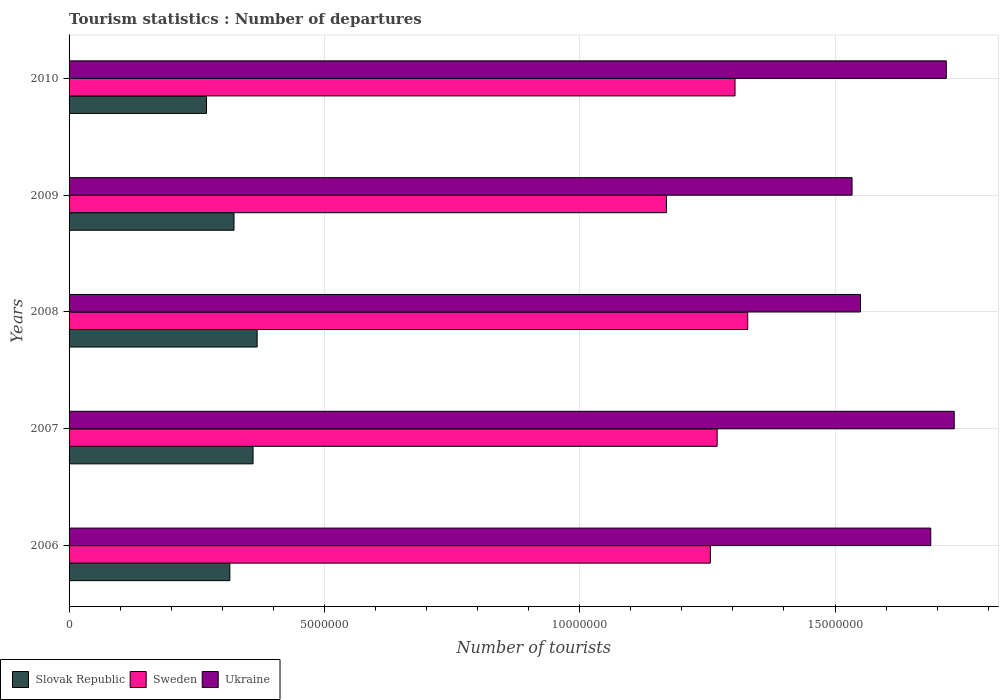How many groups of bars are there?
Keep it short and to the point. 5. Are the number of bars per tick equal to the number of legend labels?
Give a very brief answer. Yes. In how many cases, is the number of bars for a given year not equal to the number of legend labels?
Keep it short and to the point. 0. What is the number of tourist departures in Ukraine in 2007?
Make the answer very short. 1.73e+07. Across all years, what is the maximum number of tourist departures in Slovak Republic?
Ensure brevity in your answer.  3.68e+06. Across all years, what is the minimum number of tourist departures in Slovak Republic?
Ensure brevity in your answer.  2.69e+06. What is the total number of tourist departures in Ukraine in the graph?
Keep it short and to the point. 8.22e+07. What is the difference between the number of tourist departures in Ukraine in 2006 and that in 2007?
Offer a terse response. -4.60e+05. What is the difference between the number of tourist departures in Slovak Republic in 2006 and the number of tourist departures in Ukraine in 2010?
Offer a terse response. -1.40e+07. What is the average number of tourist departures in Slovak Republic per year?
Keep it short and to the point. 3.27e+06. In the year 2006, what is the difference between the number of tourist departures in Sweden and number of tourist departures in Slovak Republic?
Ensure brevity in your answer.  9.41e+06. What is the ratio of the number of tourist departures in Ukraine in 2006 to that in 2008?
Provide a short and direct response. 1.09. Is the number of tourist departures in Slovak Republic in 2008 less than that in 2010?
Your answer should be very brief. No. Is the difference between the number of tourist departures in Sweden in 2006 and 2010 greater than the difference between the number of tourist departures in Slovak Republic in 2006 and 2010?
Offer a terse response. No. What is the difference between the highest and the second highest number of tourist departures in Sweden?
Provide a succinct answer. 2.49e+05. What is the difference between the highest and the lowest number of tourist departures in Sweden?
Provide a short and direct response. 1.59e+06. What does the 1st bar from the top in 2009 represents?
Ensure brevity in your answer.  Ukraine. What does the 3rd bar from the bottom in 2008 represents?
Provide a short and direct response. Ukraine. Is it the case that in every year, the sum of the number of tourist departures in Sweden and number of tourist departures in Ukraine is greater than the number of tourist departures in Slovak Republic?
Your answer should be compact. Yes. How many bars are there?
Give a very brief answer. 15. Are all the bars in the graph horizontal?
Keep it short and to the point. Yes. How many years are there in the graph?
Offer a terse response. 5. Does the graph contain any zero values?
Provide a short and direct response. No. What is the title of the graph?
Offer a very short reply. Tourism statistics : Number of departures. What is the label or title of the X-axis?
Offer a very short reply. Number of tourists. What is the Number of tourists in Slovak Republic in 2006?
Provide a short and direct response. 3.15e+06. What is the Number of tourists of Sweden in 2006?
Offer a terse response. 1.26e+07. What is the Number of tourists of Ukraine in 2006?
Make the answer very short. 1.69e+07. What is the Number of tourists in Slovak Republic in 2007?
Give a very brief answer. 3.60e+06. What is the Number of tourists of Sweden in 2007?
Ensure brevity in your answer.  1.27e+07. What is the Number of tourists of Ukraine in 2007?
Offer a terse response. 1.73e+07. What is the Number of tourists of Slovak Republic in 2008?
Provide a succinct answer. 3.68e+06. What is the Number of tourists of Sweden in 2008?
Offer a very short reply. 1.33e+07. What is the Number of tourists of Ukraine in 2008?
Keep it short and to the point. 1.55e+07. What is the Number of tourists of Slovak Republic in 2009?
Your response must be concise. 3.23e+06. What is the Number of tourists of Sweden in 2009?
Your response must be concise. 1.17e+07. What is the Number of tourists in Ukraine in 2009?
Offer a terse response. 1.53e+07. What is the Number of tourists of Slovak Republic in 2010?
Your answer should be very brief. 2.69e+06. What is the Number of tourists of Sweden in 2010?
Make the answer very short. 1.30e+07. What is the Number of tourists of Ukraine in 2010?
Make the answer very short. 1.72e+07. Across all years, what is the maximum Number of tourists of Slovak Republic?
Offer a very short reply. 3.68e+06. Across all years, what is the maximum Number of tourists of Sweden?
Give a very brief answer. 1.33e+07. Across all years, what is the maximum Number of tourists of Ukraine?
Your answer should be very brief. 1.73e+07. Across all years, what is the minimum Number of tourists in Slovak Republic?
Ensure brevity in your answer.  2.69e+06. Across all years, what is the minimum Number of tourists of Sweden?
Your answer should be very brief. 1.17e+07. Across all years, what is the minimum Number of tourists in Ukraine?
Make the answer very short. 1.53e+07. What is the total Number of tourists of Slovak Republic in the graph?
Give a very brief answer. 1.64e+07. What is the total Number of tourists in Sweden in the graph?
Keep it short and to the point. 6.33e+07. What is the total Number of tourists of Ukraine in the graph?
Ensure brevity in your answer.  8.22e+07. What is the difference between the Number of tourists in Slovak Republic in 2006 and that in 2007?
Your response must be concise. -4.54e+05. What is the difference between the Number of tourists in Sweden in 2006 and that in 2007?
Offer a very short reply. -1.33e+05. What is the difference between the Number of tourists in Ukraine in 2006 and that in 2007?
Provide a short and direct response. -4.60e+05. What is the difference between the Number of tourists in Slovak Republic in 2006 and that in 2008?
Your answer should be compact. -5.34e+05. What is the difference between the Number of tourists in Sweden in 2006 and that in 2008?
Give a very brief answer. -7.32e+05. What is the difference between the Number of tourists of Ukraine in 2006 and that in 2008?
Make the answer very short. 1.38e+06. What is the difference between the Number of tourists in Slovak Republic in 2006 and that in 2009?
Offer a terse response. -8.10e+04. What is the difference between the Number of tourists in Sweden in 2006 and that in 2009?
Make the answer very short. 8.60e+05. What is the difference between the Number of tourists in Ukraine in 2006 and that in 2009?
Ensure brevity in your answer.  1.54e+06. What is the difference between the Number of tourists in Slovak Republic in 2006 and that in 2010?
Offer a terse response. 4.57e+05. What is the difference between the Number of tourists in Sweden in 2006 and that in 2010?
Make the answer very short. -4.83e+05. What is the difference between the Number of tourists of Ukraine in 2006 and that in 2010?
Your answer should be compact. -3.05e+05. What is the difference between the Number of tourists of Slovak Republic in 2007 and that in 2008?
Offer a very short reply. -8.00e+04. What is the difference between the Number of tourists of Sweden in 2007 and that in 2008?
Offer a terse response. -5.99e+05. What is the difference between the Number of tourists in Ukraine in 2007 and that in 2008?
Keep it short and to the point. 1.84e+06. What is the difference between the Number of tourists in Slovak Republic in 2007 and that in 2009?
Your response must be concise. 3.73e+05. What is the difference between the Number of tourists in Sweden in 2007 and that in 2009?
Keep it short and to the point. 9.93e+05. What is the difference between the Number of tourists of Ukraine in 2007 and that in 2009?
Offer a terse response. 2.00e+06. What is the difference between the Number of tourists of Slovak Republic in 2007 and that in 2010?
Offer a very short reply. 9.11e+05. What is the difference between the Number of tourists in Sweden in 2007 and that in 2010?
Offer a very short reply. -3.50e+05. What is the difference between the Number of tourists of Ukraine in 2007 and that in 2010?
Offer a terse response. 1.55e+05. What is the difference between the Number of tourists in Slovak Republic in 2008 and that in 2009?
Make the answer very short. 4.53e+05. What is the difference between the Number of tourists of Sweden in 2008 and that in 2009?
Your response must be concise. 1.59e+06. What is the difference between the Number of tourists of Ukraine in 2008 and that in 2009?
Your answer should be compact. 1.65e+05. What is the difference between the Number of tourists of Slovak Republic in 2008 and that in 2010?
Make the answer very short. 9.91e+05. What is the difference between the Number of tourists in Sweden in 2008 and that in 2010?
Keep it short and to the point. 2.49e+05. What is the difference between the Number of tourists of Ukraine in 2008 and that in 2010?
Make the answer very short. -1.68e+06. What is the difference between the Number of tourists in Slovak Republic in 2009 and that in 2010?
Provide a succinct answer. 5.38e+05. What is the difference between the Number of tourists of Sweden in 2009 and that in 2010?
Make the answer very short. -1.34e+06. What is the difference between the Number of tourists of Ukraine in 2009 and that in 2010?
Provide a succinct answer. -1.85e+06. What is the difference between the Number of tourists in Slovak Republic in 2006 and the Number of tourists in Sweden in 2007?
Offer a very short reply. -9.54e+06. What is the difference between the Number of tourists in Slovak Republic in 2006 and the Number of tourists in Ukraine in 2007?
Keep it short and to the point. -1.42e+07. What is the difference between the Number of tourists of Sweden in 2006 and the Number of tourists of Ukraine in 2007?
Your answer should be compact. -4.78e+06. What is the difference between the Number of tourists in Slovak Republic in 2006 and the Number of tourists in Sweden in 2008?
Offer a terse response. -1.01e+07. What is the difference between the Number of tourists in Slovak Republic in 2006 and the Number of tourists in Ukraine in 2008?
Keep it short and to the point. -1.24e+07. What is the difference between the Number of tourists in Sweden in 2006 and the Number of tourists in Ukraine in 2008?
Make the answer very short. -2.94e+06. What is the difference between the Number of tourists in Slovak Republic in 2006 and the Number of tourists in Sweden in 2009?
Make the answer very short. -8.55e+06. What is the difference between the Number of tourists in Slovak Republic in 2006 and the Number of tourists in Ukraine in 2009?
Your answer should be compact. -1.22e+07. What is the difference between the Number of tourists in Sweden in 2006 and the Number of tourists in Ukraine in 2009?
Provide a short and direct response. -2.78e+06. What is the difference between the Number of tourists of Slovak Republic in 2006 and the Number of tourists of Sweden in 2010?
Keep it short and to the point. -9.89e+06. What is the difference between the Number of tourists of Slovak Republic in 2006 and the Number of tourists of Ukraine in 2010?
Make the answer very short. -1.40e+07. What is the difference between the Number of tourists of Sweden in 2006 and the Number of tourists of Ukraine in 2010?
Your response must be concise. -4.62e+06. What is the difference between the Number of tourists in Slovak Republic in 2007 and the Number of tourists in Sweden in 2008?
Give a very brief answer. -9.69e+06. What is the difference between the Number of tourists in Slovak Republic in 2007 and the Number of tourists in Ukraine in 2008?
Make the answer very short. -1.19e+07. What is the difference between the Number of tourists in Sweden in 2007 and the Number of tourists in Ukraine in 2008?
Ensure brevity in your answer.  -2.81e+06. What is the difference between the Number of tourists in Slovak Republic in 2007 and the Number of tourists in Sweden in 2009?
Make the answer very short. -8.10e+06. What is the difference between the Number of tourists in Slovak Republic in 2007 and the Number of tourists in Ukraine in 2009?
Offer a very short reply. -1.17e+07. What is the difference between the Number of tourists of Sweden in 2007 and the Number of tourists of Ukraine in 2009?
Provide a succinct answer. -2.64e+06. What is the difference between the Number of tourists in Slovak Republic in 2007 and the Number of tourists in Sweden in 2010?
Offer a very short reply. -9.44e+06. What is the difference between the Number of tourists of Slovak Republic in 2007 and the Number of tourists of Ukraine in 2010?
Keep it short and to the point. -1.36e+07. What is the difference between the Number of tourists of Sweden in 2007 and the Number of tourists of Ukraine in 2010?
Ensure brevity in your answer.  -4.49e+06. What is the difference between the Number of tourists in Slovak Republic in 2008 and the Number of tourists in Sweden in 2009?
Offer a very short reply. -8.02e+06. What is the difference between the Number of tourists in Slovak Republic in 2008 and the Number of tourists in Ukraine in 2009?
Your answer should be very brief. -1.17e+07. What is the difference between the Number of tourists in Sweden in 2008 and the Number of tourists in Ukraine in 2009?
Make the answer very short. -2.04e+06. What is the difference between the Number of tourists in Slovak Republic in 2008 and the Number of tourists in Sweden in 2010?
Make the answer very short. -9.36e+06. What is the difference between the Number of tourists of Slovak Republic in 2008 and the Number of tourists of Ukraine in 2010?
Give a very brief answer. -1.35e+07. What is the difference between the Number of tourists in Sweden in 2008 and the Number of tourists in Ukraine in 2010?
Give a very brief answer. -3.89e+06. What is the difference between the Number of tourists of Slovak Republic in 2009 and the Number of tourists of Sweden in 2010?
Provide a short and direct response. -9.81e+06. What is the difference between the Number of tourists in Slovak Republic in 2009 and the Number of tourists in Ukraine in 2010?
Make the answer very short. -1.40e+07. What is the difference between the Number of tourists in Sweden in 2009 and the Number of tourists in Ukraine in 2010?
Give a very brief answer. -5.48e+06. What is the average Number of tourists in Slovak Republic per year?
Your answer should be very brief. 3.27e+06. What is the average Number of tourists in Sweden per year?
Make the answer very short. 1.27e+07. What is the average Number of tourists in Ukraine per year?
Ensure brevity in your answer.  1.64e+07. In the year 2006, what is the difference between the Number of tourists of Slovak Republic and Number of tourists of Sweden?
Provide a succinct answer. -9.41e+06. In the year 2006, what is the difference between the Number of tourists of Slovak Republic and Number of tourists of Ukraine?
Ensure brevity in your answer.  -1.37e+07. In the year 2006, what is the difference between the Number of tourists in Sweden and Number of tourists in Ukraine?
Offer a very short reply. -4.32e+06. In the year 2007, what is the difference between the Number of tourists of Slovak Republic and Number of tourists of Sweden?
Give a very brief answer. -9.09e+06. In the year 2007, what is the difference between the Number of tourists of Slovak Republic and Number of tourists of Ukraine?
Give a very brief answer. -1.37e+07. In the year 2007, what is the difference between the Number of tourists of Sweden and Number of tourists of Ukraine?
Offer a terse response. -4.64e+06. In the year 2008, what is the difference between the Number of tourists in Slovak Republic and Number of tourists in Sweden?
Offer a very short reply. -9.61e+06. In the year 2008, what is the difference between the Number of tourists of Slovak Republic and Number of tourists of Ukraine?
Your response must be concise. -1.18e+07. In the year 2008, what is the difference between the Number of tourists of Sweden and Number of tourists of Ukraine?
Make the answer very short. -2.21e+06. In the year 2009, what is the difference between the Number of tourists in Slovak Republic and Number of tourists in Sweden?
Provide a short and direct response. -8.47e+06. In the year 2009, what is the difference between the Number of tourists in Slovak Republic and Number of tourists in Ukraine?
Ensure brevity in your answer.  -1.21e+07. In the year 2009, what is the difference between the Number of tourists of Sweden and Number of tourists of Ukraine?
Offer a terse response. -3.64e+06. In the year 2010, what is the difference between the Number of tourists of Slovak Republic and Number of tourists of Sweden?
Keep it short and to the point. -1.04e+07. In the year 2010, what is the difference between the Number of tourists in Slovak Republic and Number of tourists in Ukraine?
Ensure brevity in your answer.  -1.45e+07. In the year 2010, what is the difference between the Number of tourists in Sweden and Number of tourists in Ukraine?
Your response must be concise. -4.14e+06. What is the ratio of the Number of tourists in Slovak Republic in 2006 to that in 2007?
Provide a succinct answer. 0.87. What is the ratio of the Number of tourists in Ukraine in 2006 to that in 2007?
Your answer should be compact. 0.97. What is the ratio of the Number of tourists of Slovak Republic in 2006 to that in 2008?
Give a very brief answer. 0.85. What is the ratio of the Number of tourists in Sweden in 2006 to that in 2008?
Provide a succinct answer. 0.94. What is the ratio of the Number of tourists in Ukraine in 2006 to that in 2008?
Make the answer very short. 1.09. What is the ratio of the Number of tourists of Slovak Republic in 2006 to that in 2009?
Provide a succinct answer. 0.97. What is the ratio of the Number of tourists of Sweden in 2006 to that in 2009?
Your response must be concise. 1.07. What is the ratio of the Number of tourists of Ukraine in 2006 to that in 2009?
Provide a short and direct response. 1.1. What is the ratio of the Number of tourists of Slovak Republic in 2006 to that in 2010?
Offer a very short reply. 1.17. What is the ratio of the Number of tourists of Sweden in 2006 to that in 2010?
Offer a very short reply. 0.96. What is the ratio of the Number of tourists of Ukraine in 2006 to that in 2010?
Provide a short and direct response. 0.98. What is the ratio of the Number of tourists in Slovak Republic in 2007 to that in 2008?
Provide a short and direct response. 0.98. What is the ratio of the Number of tourists in Sweden in 2007 to that in 2008?
Your answer should be compact. 0.95. What is the ratio of the Number of tourists in Ukraine in 2007 to that in 2008?
Make the answer very short. 1.12. What is the ratio of the Number of tourists of Slovak Republic in 2007 to that in 2009?
Ensure brevity in your answer.  1.12. What is the ratio of the Number of tourists of Sweden in 2007 to that in 2009?
Keep it short and to the point. 1.08. What is the ratio of the Number of tourists of Ukraine in 2007 to that in 2009?
Make the answer very short. 1.13. What is the ratio of the Number of tourists of Slovak Republic in 2007 to that in 2010?
Keep it short and to the point. 1.34. What is the ratio of the Number of tourists in Sweden in 2007 to that in 2010?
Make the answer very short. 0.97. What is the ratio of the Number of tourists of Slovak Republic in 2008 to that in 2009?
Provide a short and direct response. 1.14. What is the ratio of the Number of tourists in Sweden in 2008 to that in 2009?
Give a very brief answer. 1.14. What is the ratio of the Number of tourists in Ukraine in 2008 to that in 2009?
Your response must be concise. 1.01. What is the ratio of the Number of tourists in Slovak Republic in 2008 to that in 2010?
Keep it short and to the point. 1.37. What is the ratio of the Number of tourists of Sweden in 2008 to that in 2010?
Ensure brevity in your answer.  1.02. What is the ratio of the Number of tourists in Ukraine in 2008 to that in 2010?
Your response must be concise. 0.9. What is the ratio of the Number of tourists of Slovak Republic in 2009 to that in 2010?
Your answer should be compact. 1.2. What is the ratio of the Number of tourists in Sweden in 2009 to that in 2010?
Provide a succinct answer. 0.9. What is the ratio of the Number of tourists of Ukraine in 2009 to that in 2010?
Give a very brief answer. 0.89. What is the difference between the highest and the second highest Number of tourists of Sweden?
Keep it short and to the point. 2.49e+05. What is the difference between the highest and the second highest Number of tourists in Ukraine?
Offer a very short reply. 1.55e+05. What is the difference between the highest and the lowest Number of tourists in Slovak Republic?
Your response must be concise. 9.91e+05. What is the difference between the highest and the lowest Number of tourists of Sweden?
Provide a succinct answer. 1.59e+06. What is the difference between the highest and the lowest Number of tourists in Ukraine?
Provide a short and direct response. 2.00e+06. 